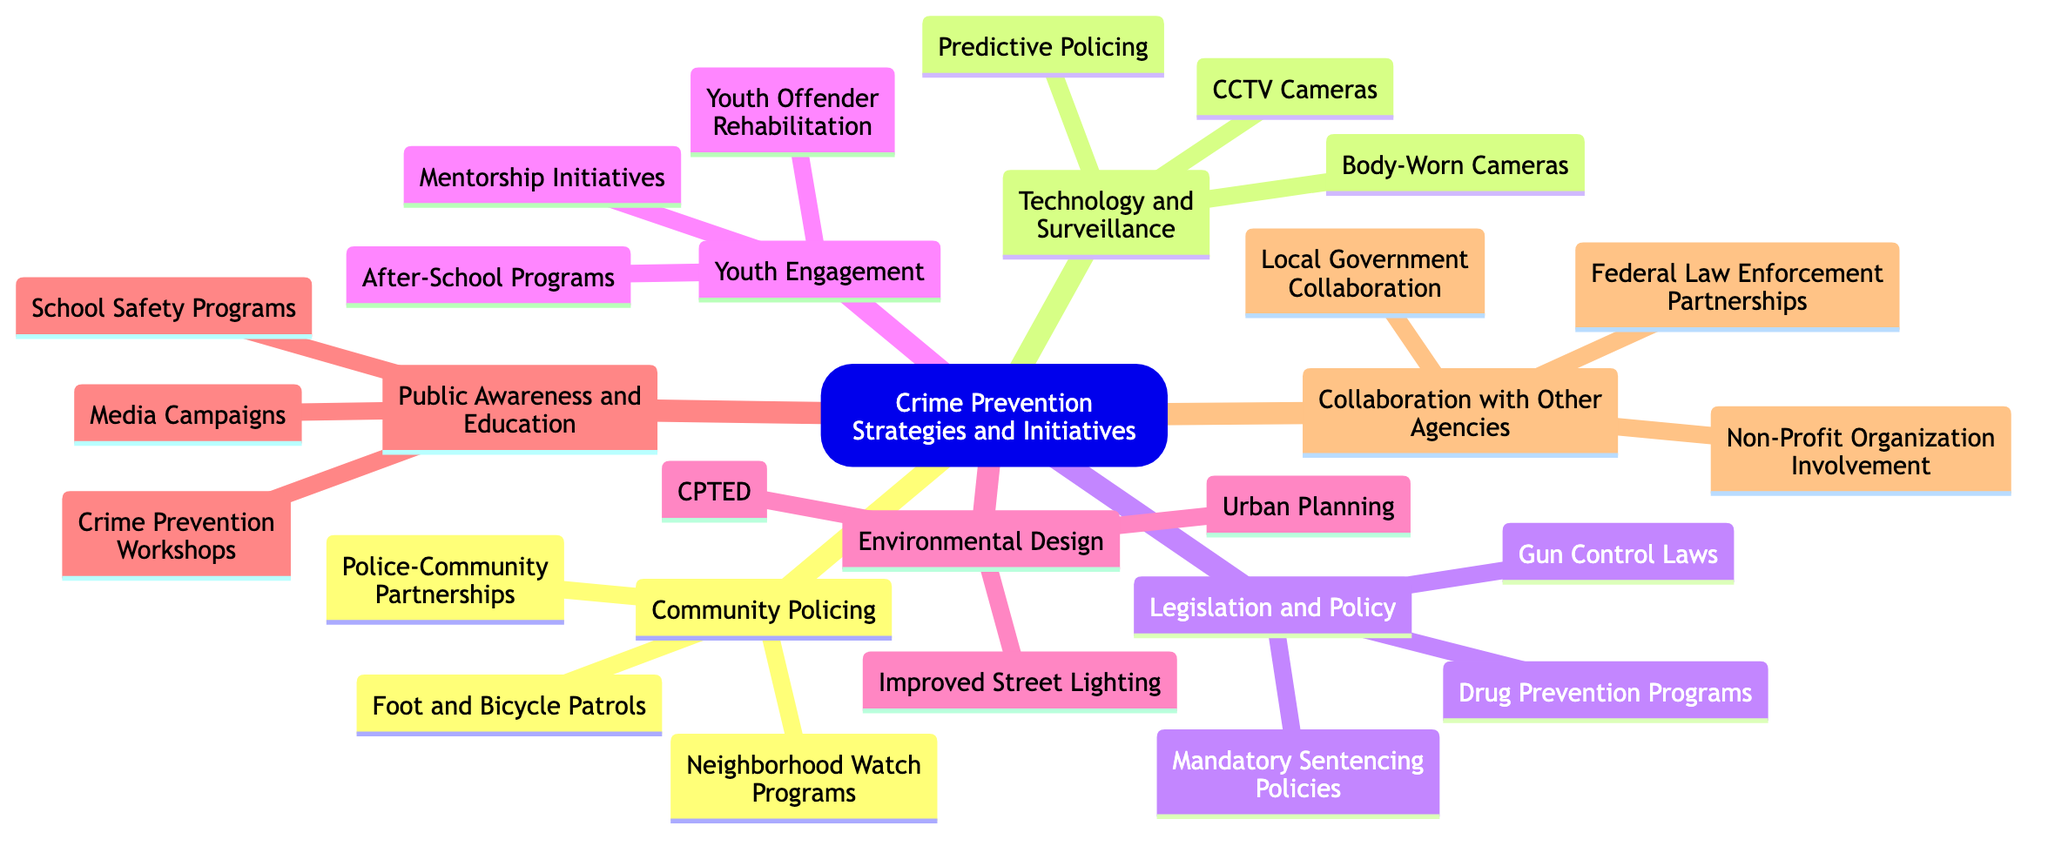What are the main categories of crime prevention strategies? The main categories in the diagram are Community Policing, Technology and Surveillance, Legislation and Policy, Youth Engagement, Environmental Design, Public Awareness and Education, and Collaboration with Other Agencies.
Answer: Community Policing, Technology and Surveillance, Legislation and Policy, Youth Engagement, Environmental Design, Public Awareness and Education, Collaboration with Other Agencies How many initiatives are listed under Technology and Surveillance? In the Technology and Surveillance category, there are three initiatives: CCTV Cameras, Predictive Policing, and Body-Worn Cameras.
Answer: 3 What is one example of a strategy in Youth Engagement? A strategy listed under Youth Engagement is After-School Programs, which helps to engage youth positively and prevent crime.
Answer: After-School Programs Which category does Improved Street Lighting belong to? Improved Street Lighting is part of the Environmental Design category, focusing on crime prevention through better physical environments.
Answer: Environmental Design What type of initiatives can be found under Collaboration with Other Agencies? The initiatives listed under Collaboration with Other Agencies include Federal Law Enforcement Partnerships, Local Government Collaboration, and Non-Profit Organization Involvement.
Answer: Federal Law Enforcement Partnerships, Local Government Collaboration, Non-Profit Organization Involvement How many total initiatives are outlined in the diagram? To calculate the total, count all the listed initiatives: 3 (Community Policing) + 3 (Technology and Surveillance) + 3 (Legislation and Policy) + 3 (Youth Engagement) + 3 (Environmental Design) + 3 (Public Awareness and Education) + 3 (Collaboration with Other Agencies) equals 21 initiatives in total.
Answer: 21 What initiative falls under Public Awareness and Education? One of the initiatives under Public Awareness and Education is Crime Prevention Workshops, aimed at educating the community on crime prevention.
Answer: Crime Prevention Workshops What is the relationship between Police-Community Partnerships and Community Policing? Police-Community Partnerships is a specific initiative under the broader category of Community Policing, emphasizing collaboration between law enforcement and the community.
Answer: Community Policing Which legislation-related initiative is concerned with drug issues? The initiative concerned with drug issues under Legislation and Policy is Drug Prevention Programs, aimed at addressing drug-related crimes through educational and legislative actions.
Answer: Drug Prevention Programs 